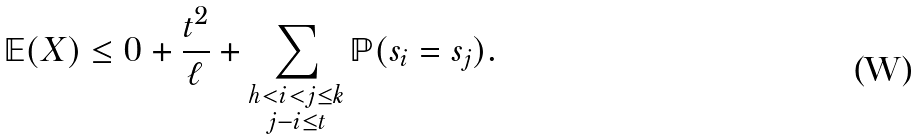<formula> <loc_0><loc_0><loc_500><loc_500>\mathbb { E } ( X ) \leq 0 + \frac { t ^ { 2 } } { \ell } + \sum _ { \substack { h < i < j \leq k \\ j - i \leq t } } \mathbb { P } ( s _ { i } = s _ { j } ) .</formula> 